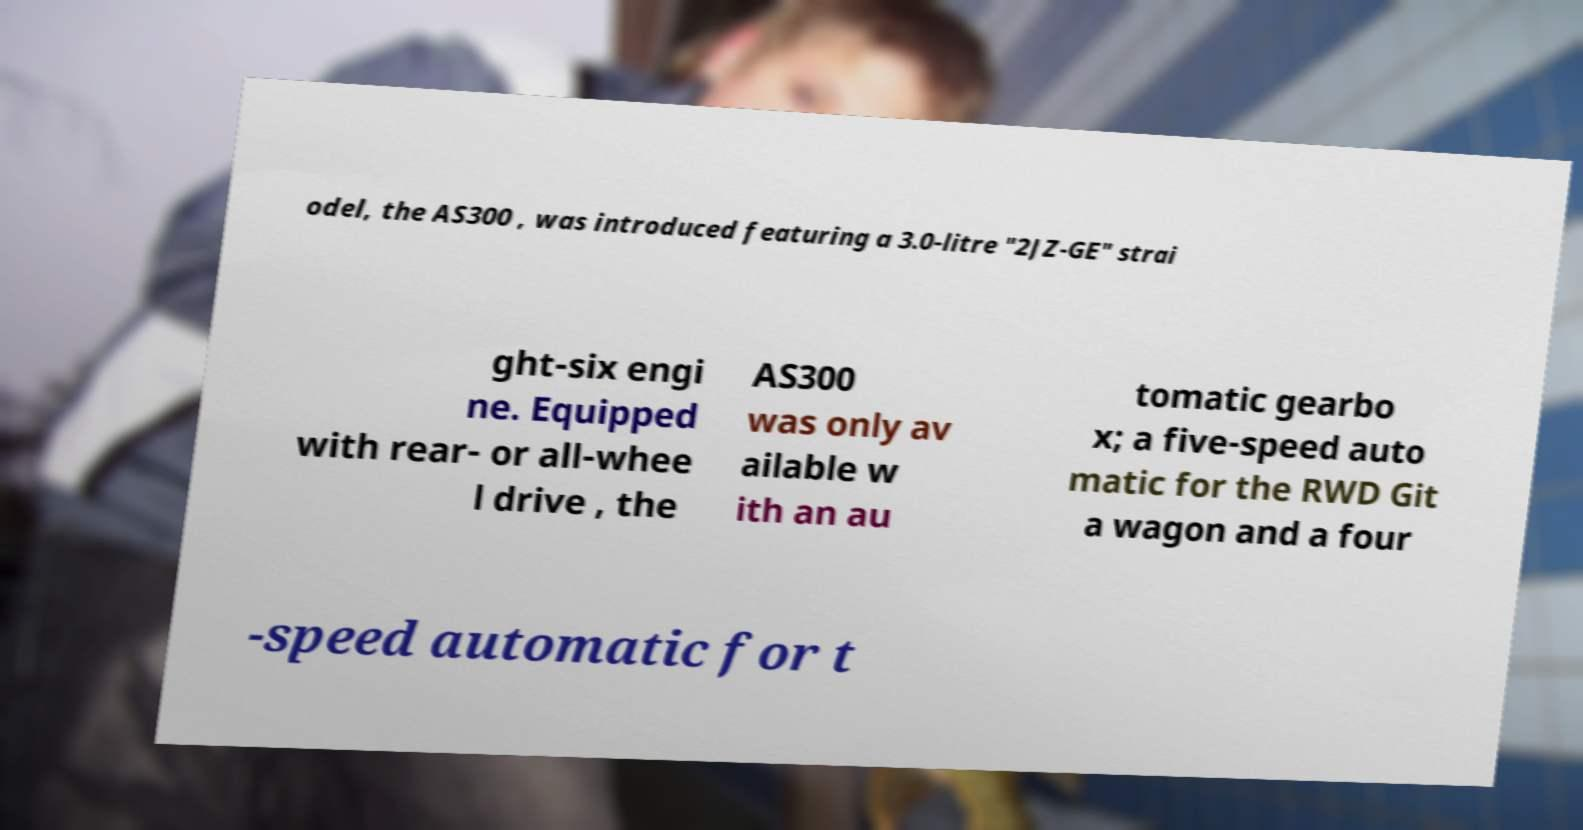Please read and relay the text visible in this image. What does it say? odel, the AS300 , was introduced featuring a 3.0-litre "2JZ-GE" strai ght-six engi ne. Equipped with rear- or all-whee l drive , the AS300 was only av ailable w ith an au tomatic gearbo x; a five-speed auto matic for the RWD Git a wagon and a four -speed automatic for t 